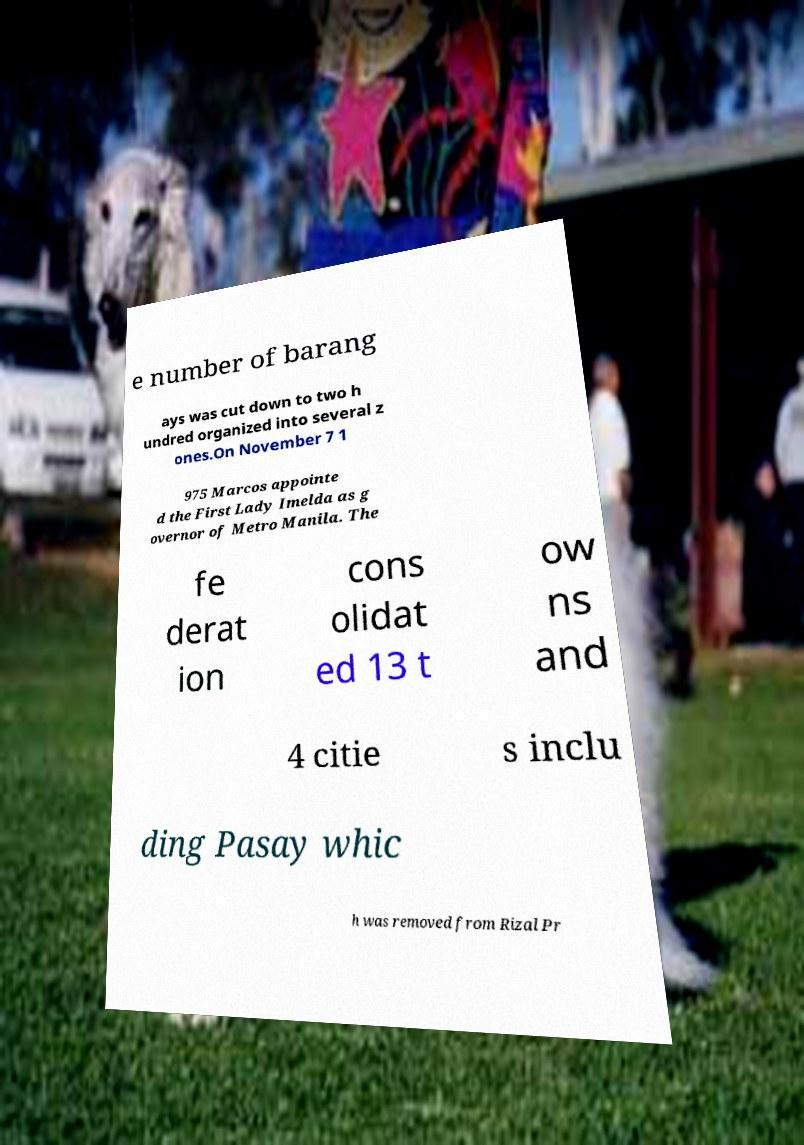What messages or text are displayed in this image? I need them in a readable, typed format. e number of barang ays was cut down to two h undred organized into several z ones.On November 7 1 975 Marcos appointe d the First Lady Imelda as g overnor of Metro Manila. The fe derat ion cons olidat ed 13 t ow ns and 4 citie s inclu ding Pasay whic h was removed from Rizal Pr 